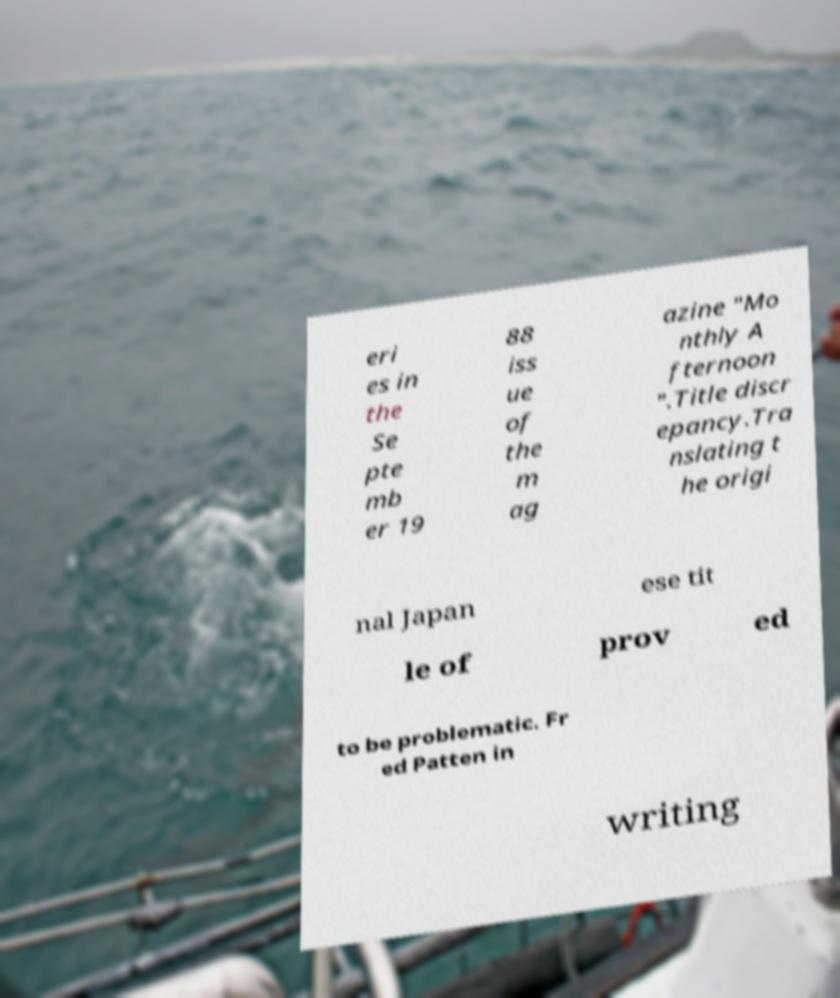Could you assist in decoding the text presented in this image and type it out clearly? eri es in the Se pte mb er 19 88 iss ue of the m ag azine "Mo nthly A fternoon ".Title discr epancy.Tra nslating t he origi nal Japan ese tit le of prov ed to be problematic. Fr ed Patten in writing 